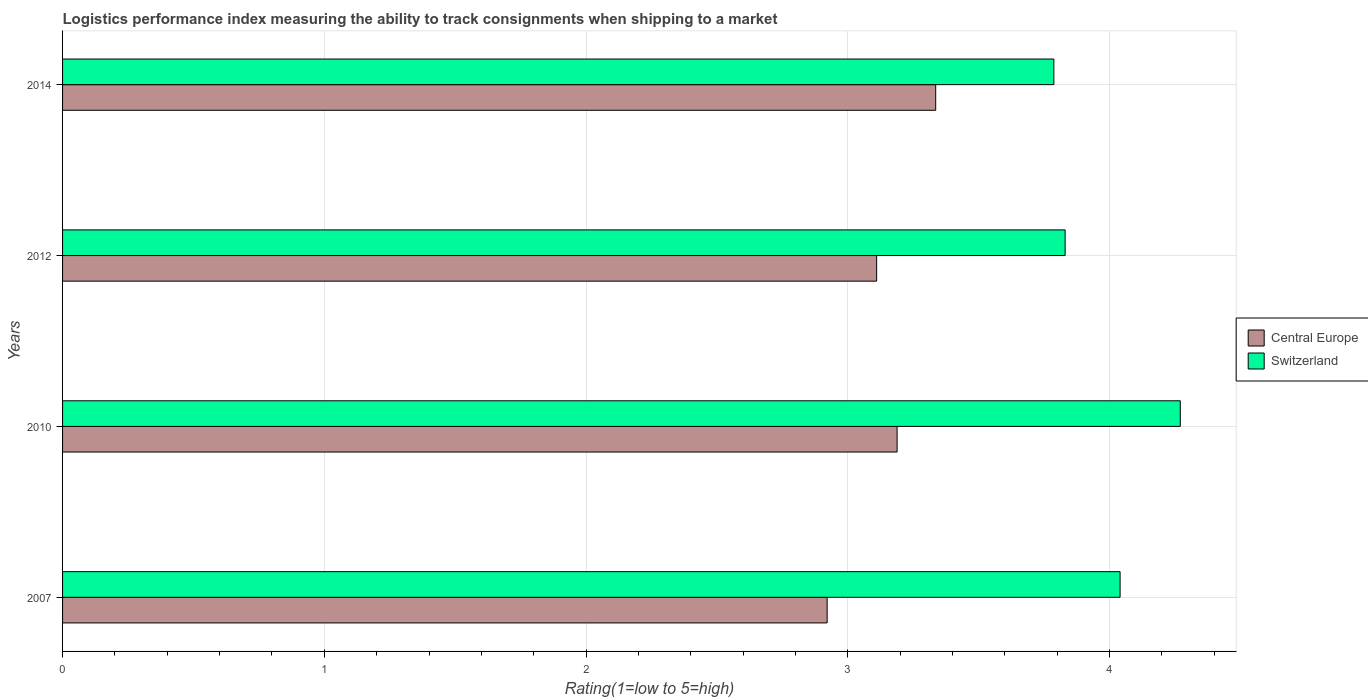How many different coloured bars are there?
Keep it short and to the point. 2. How many groups of bars are there?
Offer a very short reply. 4. What is the label of the 1st group of bars from the top?
Your answer should be compact. 2014. In how many cases, is the number of bars for a given year not equal to the number of legend labels?
Give a very brief answer. 0. What is the Logistic performance index in Central Europe in 2010?
Offer a terse response. 3.19. Across all years, what is the maximum Logistic performance index in Switzerland?
Make the answer very short. 4.27. Across all years, what is the minimum Logistic performance index in Central Europe?
Your response must be concise. 2.92. In which year was the Logistic performance index in Switzerland minimum?
Give a very brief answer. 2014. What is the total Logistic performance index in Central Europe in the graph?
Give a very brief answer. 12.55. What is the difference between the Logistic performance index in Central Europe in 2007 and that in 2014?
Make the answer very short. -0.41. What is the difference between the Logistic performance index in Switzerland in 2010 and the Logistic performance index in Central Europe in 2007?
Offer a very short reply. 1.35. What is the average Logistic performance index in Switzerland per year?
Your answer should be compact. 3.98. In the year 2007, what is the difference between the Logistic performance index in Switzerland and Logistic performance index in Central Europe?
Provide a succinct answer. 1.12. What is the ratio of the Logistic performance index in Central Europe in 2010 to that in 2014?
Provide a succinct answer. 0.96. What is the difference between the highest and the second highest Logistic performance index in Central Europe?
Your answer should be very brief. 0.15. What is the difference between the highest and the lowest Logistic performance index in Central Europe?
Provide a succinct answer. 0.41. In how many years, is the Logistic performance index in Central Europe greater than the average Logistic performance index in Central Europe taken over all years?
Your answer should be compact. 2. What does the 2nd bar from the top in 2010 represents?
Ensure brevity in your answer.  Central Europe. What does the 2nd bar from the bottom in 2012 represents?
Your response must be concise. Switzerland. How many bars are there?
Offer a terse response. 8. What is the difference between two consecutive major ticks on the X-axis?
Your answer should be very brief. 1. Are the values on the major ticks of X-axis written in scientific E-notation?
Your answer should be compact. No. What is the title of the graph?
Your answer should be compact. Logistics performance index measuring the ability to track consignments when shipping to a market. Does "New Zealand" appear as one of the legend labels in the graph?
Offer a very short reply. No. What is the label or title of the X-axis?
Keep it short and to the point. Rating(1=low to 5=high). What is the label or title of the Y-axis?
Provide a succinct answer. Years. What is the Rating(1=low to 5=high) of Central Europe in 2007?
Provide a short and direct response. 2.92. What is the Rating(1=low to 5=high) in Switzerland in 2007?
Give a very brief answer. 4.04. What is the Rating(1=low to 5=high) of Central Europe in 2010?
Provide a short and direct response. 3.19. What is the Rating(1=low to 5=high) of Switzerland in 2010?
Provide a succinct answer. 4.27. What is the Rating(1=low to 5=high) of Central Europe in 2012?
Give a very brief answer. 3.11. What is the Rating(1=low to 5=high) of Switzerland in 2012?
Your answer should be compact. 3.83. What is the Rating(1=low to 5=high) of Central Europe in 2014?
Make the answer very short. 3.34. What is the Rating(1=low to 5=high) in Switzerland in 2014?
Your answer should be compact. 3.79. Across all years, what is the maximum Rating(1=low to 5=high) in Central Europe?
Provide a succinct answer. 3.34. Across all years, what is the maximum Rating(1=low to 5=high) of Switzerland?
Your response must be concise. 4.27. Across all years, what is the minimum Rating(1=low to 5=high) of Central Europe?
Offer a terse response. 2.92. Across all years, what is the minimum Rating(1=low to 5=high) of Switzerland?
Your answer should be very brief. 3.79. What is the total Rating(1=low to 5=high) of Central Europe in the graph?
Give a very brief answer. 12.55. What is the total Rating(1=low to 5=high) of Switzerland in the graph?
Offer a terse response. 15.93. What is the difference between the Rating(1=low to 5=high) in Central Europe in 2007 and that in 2010?
Provide a succinct answer. -0.27. What is the difference between the Rating(1=low to 5=high) of Switzerland in 2007 and that in 2010?
Offer a terse response. -0.23. What is the difference between the Rating(1=low to 5=high) of Central Europe in 2007 and that in 2012?
Ensure brevity in your answer.  -0.19. What is the difference between the Rating(1=low to 5=high) of Switzerland in 2007 and that in 2012?
Offer a very short reply. 0.21. What is the difference between the Rating(1=low to 5=high) of Central Europe in 2007 and that in 2014?
Your answer should be very brief. -0.41. What is the difference between the Rating(1=low to 5=high) in Switzerland in 2007 and that in 2014?
Offer a very short reply. 0.25. What is the difference between the Rating(1=low to 5=high) in Central Europe in 2010 and that in 2012?
Offer a very short reply. 0.08. What is the difference between the Rating(1=low to 5=high) in Switzerland in 2010 and that in 2012?
Offer a very short reply. 0.44. What is the difference between the Rating(1=low to 5=high) of Central Europe in 2010 and that in 2014?
Keep it short and to the point. -0.15. What is the difference between the Rating(1=low to 5=high) in Switzerland in 2010 and that in 2014?
Offer a very short reply. 0.48. What is the difference between the Rating(1=low to 5=high) of Central Europe in 2012 and that in 2014?
Make the answer very short. -0.23. What is the difference between the Rating(1=low to 5=high) of Switzerland in 2012 and that in 2014?
Ensure brevity in your answer.  0.04. What is the difference between the Rating(1=low to 5=high) in Central Europe in 2007 and the Rating(1=low to 5=high) in Switzerland in 2010?
Offer a very short reply. -1.35. What is the difference between the Rating(1=low to 5=high) in Central Europe in 2007 and the Rating(1=low to 5=high) in Switzerland in 2012?
Ensure brevity in your answer.  -0.91. What is the difference between the Rating(1=low to 5=high) of Central Europe in 2007 and the Rating(1=low to 5=high) of Switzerland in 2014?
Offer a very short reply. -0.87. What is the difference between the Rating(1=low to 5=high) in Central Europe in 2010 and the Rating(1=low to 5=high) in Switzerland in 2012?
Provide a short and direct response. -0.64. What is the difference between the Rating(1=low to 5=high) of Central Europe in 2010 and the Rating(1=low to 5=high) of Switzerland in 2014?
Your response must be concise. -0.6. What is the difference between the Rating(1=low to 5=high) in Central Europe in 2012 and the Rating(1=low to 5=high) in Switzerland in 2014?
Offer a terse response. -0.68. What is the average Rating(1=low to 5=high) of Central Europe per year?
Make the answer very short. 3.14. What is the average Rating(1=low to 5=high) in Switzerland per year?
Ensure brevity in your answer.  3.98. In the year 2007, what is the difference between the Rating(1=low to 5=high) in Central Europe and Rating(1=low to 5=high) in Switzerland?
Your answer should be compact. -1.12. In the year 2010, what is the difference between the Rating(1=low to 5=high) in Central Europe and Rating(1=low to 5=high) in Switzerland?
Provide a short and direct response. -1.08. In the year 2012, what is the difference between the Rating(1=low to 5=high) of Central Europe and Rating(1=low to 5=high) of Switzerland?
Your response must be concise. -0.72. In the year 2014, what is the difference between the Rating(1=low to 5=high) in Central Europe and Rating(1=low to 5=high) in Switzerland?
Keep it short and to the point. -0.45. What is the ratio of the Rating(1=low to 5=high) of Central Europe in 2007 to that in 2010?
Make the answer very short. 0.92. What is the ratio of the Rating(1=low to 5=high) in Switzerland in 2007 to that in 2010?
Offer a very short reply. 0.95. What is the ratio of the Rating(1=low to 5=high) in Central Europe in 2007 to that in 2012?
Offer a terse response. 0.94. What is the ratio of the Rating(1=low to 5=high) in Switzerland in 2007 to that in 2012?
Your answer should be very brief. 1.05. What is the ratio of the Rating(1=low to 5=high) of Central Europe in 2007 to that in 2014?
Your answer should be very brief. 0.88. What is the ratio of the Rating(1=low to 5=high) of Switzerland in 2007 to that in 2014?
Make the answer very short. 1.07. What is the ratio of the Rating(1=low to 5=high) of Central Europe in 2010 to that in 2012?
Your response must be concise. 1.03. What is the ratio of the Rating(1=low to 5=high) in Switzerland in 2010 to that in 2012?
Make the answer very short. 1.11. What is the ratio of the Rating(1=low to 5=high) of Central Europe in 2010 to that in 2014?
Provide a succinct answer. 0.96. What is the ratio of the Rating(1=low to 5=high) in Switzerland in 2010 to that in 2014?
Your answer should be compact. 1.13. What is the ratio of the Rating(1=low to 5=high) in Central Europe in 2012 to that in 2014?
Give a very brief answer. 0.93. What is the ratio of the Rating(1=low to 5=high) in Switzerland in 2012 to that in 2014?
Your answer should be compact. 1.01. What is the difference between the highest and the second highest Rating(1=low to 5=high) in Central Europe?
Provide a short and direct response. 0.15. What is the difference between the highest and the second highest Rating(1=low to 5=high) in Switzerland?
Provide a short and direct response. 0.23. What is the difference between the highest and the lowest Rating(1=low to 5=high) of Central Europe?
Offer a very short reply. 0.41. What is the difference between the highest and the lowest Rating(1=low to 5=high) of Switzerland?
Make the answer very short. 0.48. 